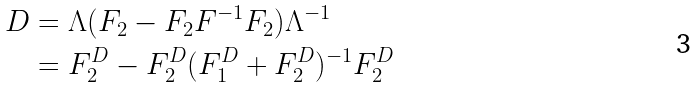<formula> <loc_0><loc_0><loc_500><loc_500>D & = \Lambda ( F _ { 2 } - F _ { 2 } F ^ { - 1 } F _ { 2 } ) \Lambda ^ { - 1 } \\ & = F _ { 2 } ^ { D } - F _ { 2 } ^ { D } ( F _ { 1 } ^ { D } + F _ { 2 } ^ { D } ) ^ { - 1 } F _ { 2 } ^ { D }</formula> 